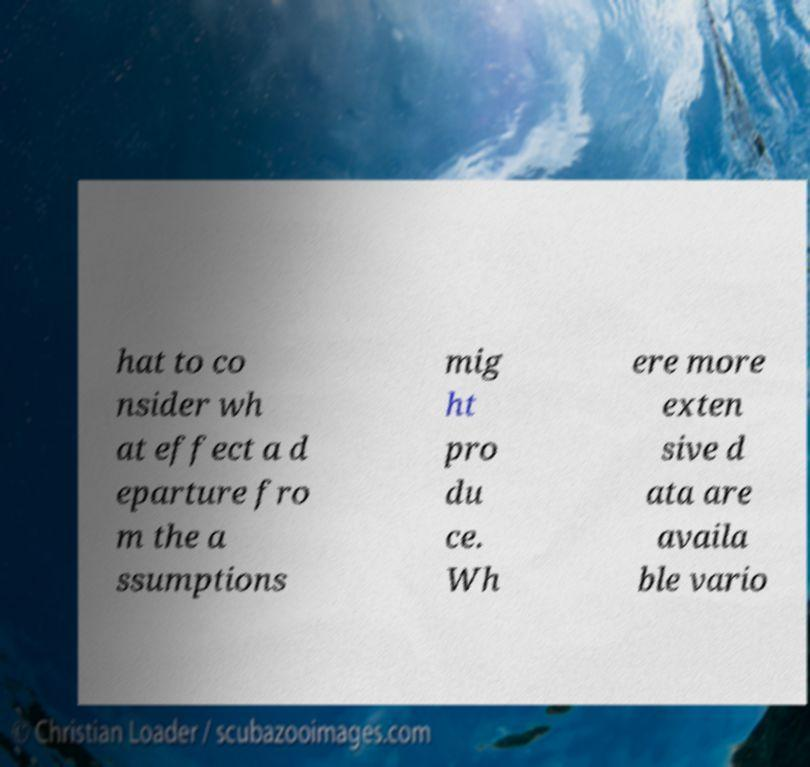There's text embedded in this image that I need extracted. Can you transcribe it verbatim? hat to co nsider wh at effect a d eparture fro m the a ssumptions mig ht pro du ce. Wh ere more exten sive d ata are availa ble vario 